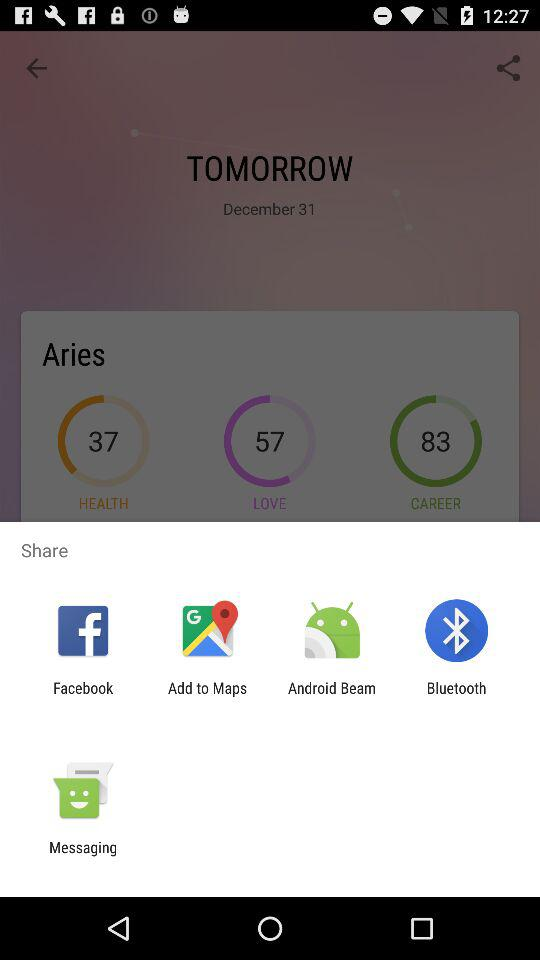What are the sharing options? The sharing options are "Facebook", "Add to Maps", "Android Beam", "Bluetooth" and "Messaging". 